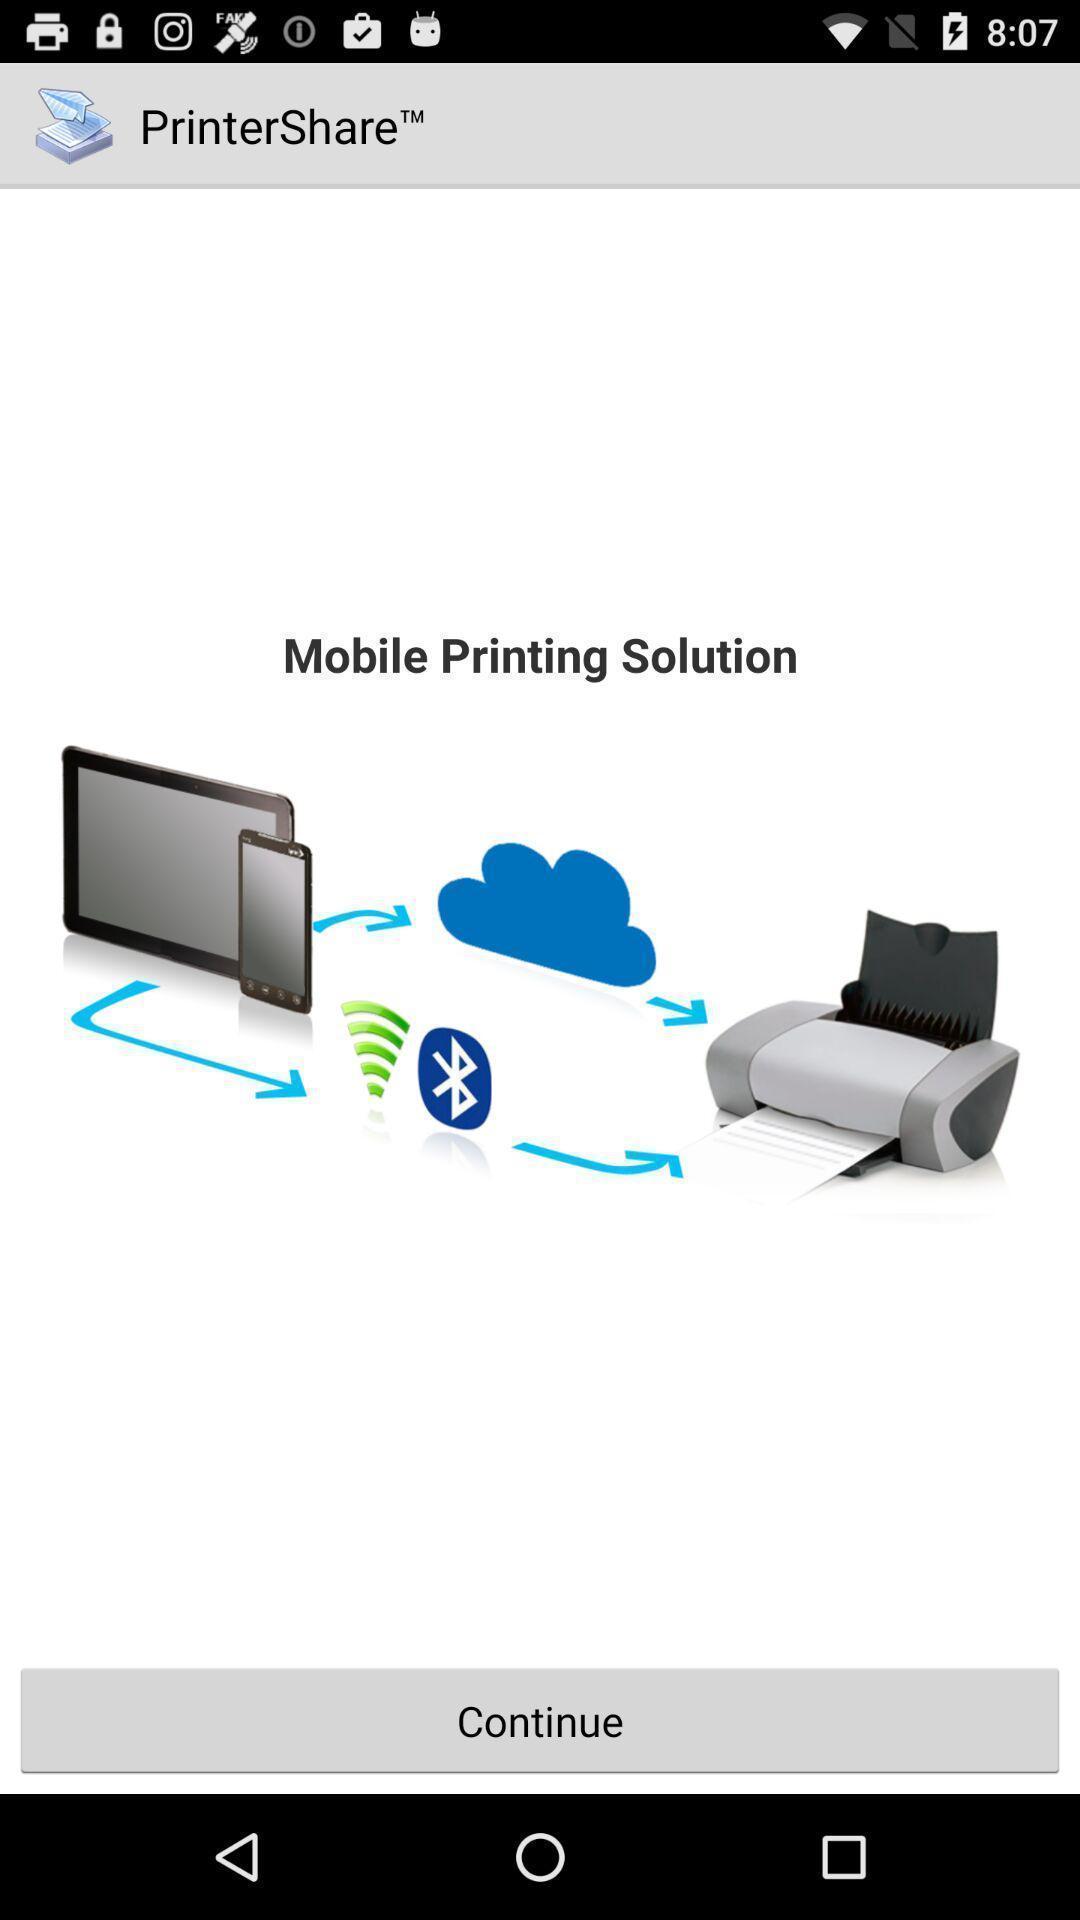Describe the content in this image. Page showing continue option. 